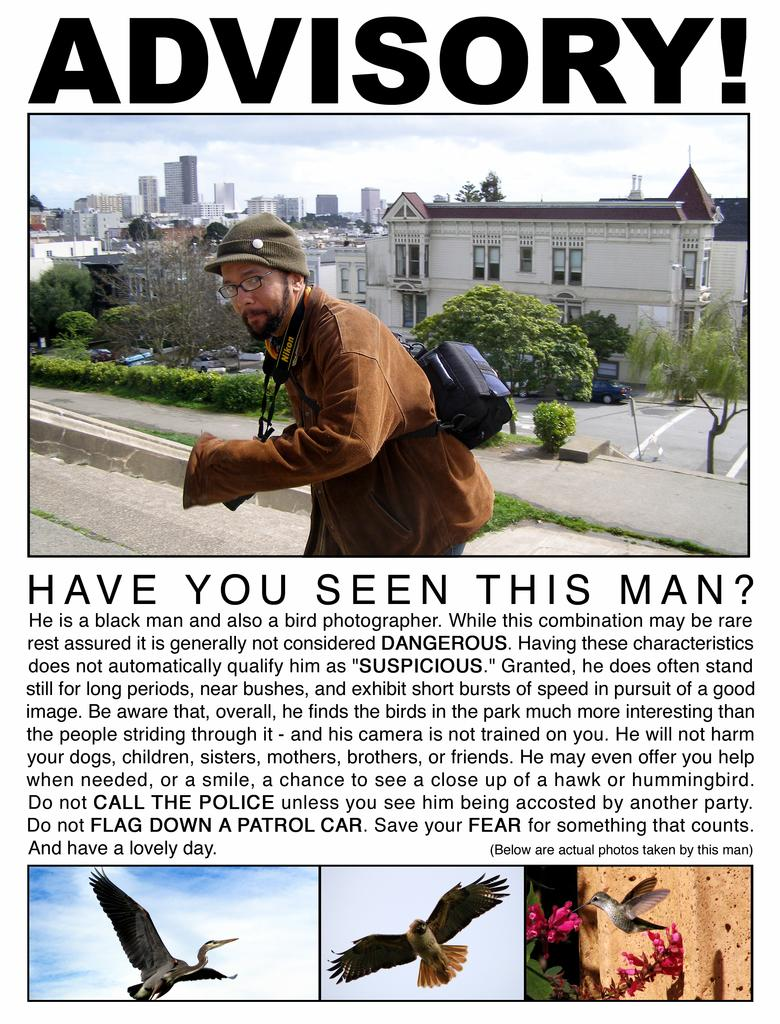What types of living organisms are depicted on the poster? The poster contains images of birds, trees, and plants. What types of structures are depicted on the poster? The poster contains images of houses and buildings. Who is depicted on the poster? The poster contains an image of a man. What else is featured on the poster besides images? The poster contains text. What type of receipt is visible on the poster? There is no receipt present on the poster. What type of government is depicted in the image of the man on the poster? The image of the man on the poster does not depict any government or political affiliation. 